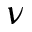<formula> <loc_0><loc_0><loc_500><loc_500>\nu</formula> 